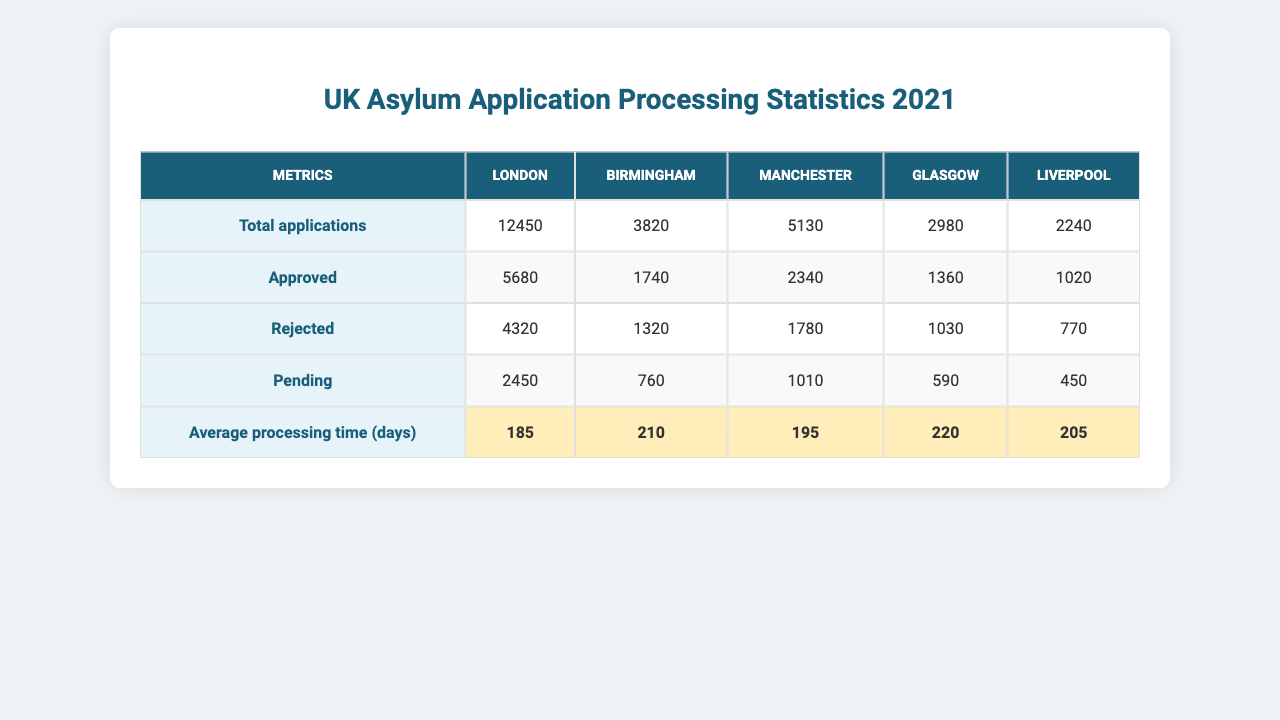What is the total number of asylum applications in London? The table shows that London has 12,450 asylum applications listed under "Total applications."
Answer: 12,450 How many applications were approved in Birmingham? According to the table, Birmingham has 1,740 applications approved.
Answer: 1,740 Which city had the highest number of rejected applications? By examining the "Rejected" column, London has the highest number of rejected applications at 4,320.
Answer: London What is the average processing time for applications in Manchester? The table indicates that the average processing time in Manchester is 195 days.
Answer: 195 days How many pending applications are there in Liverpool? The table shows that Liverpool has 450 pending applications.
Answer: 450 Which city had the lowest total asylum applications? Reviewing the "Total applications" row, Liverpool has the lowest total with 2,240 applications.
Answer: Liverpool What is the sum of approved applications across all cities? The approved applications are: London (5,680) + Birmingham (1,740) + Manchester (2,340) + Glasgow (1,360) + Liverpool (1,020), totaling 12,140 approved applications.
Answer: 12,140 Is the average processing time in Glasgow higher than in Birmingham? Glasgow has an average processing time of 220 days, while Birmingham has 210 days, indicating that Glasgow is indeed higher.
Answer: Yes What is the difference in total applications between London and Birmingham? The difference is calculated as 12,450 (London) - 3,820 (Birmingham) = 8,630 applications.
Answer: 8,630 Which city has the highest number of pending applications? Looking at the "Pending" column, London has 2,450 pending applications, which is the highest among all cities listed.
Answer: London If we consider the total number of applications and their approval rates, which city has the highest approval rate? The approval rate is calculated by dividing approved applications by total applications. For example, for London, it's 5,680/12,450 = ~45.7%. Doing this for all cities shows that Birmingham has the highest approval rate at approximately 45.7%.
Answer: Birmingham What is the average processing time of applications for cities with more than 5,000 total applications? The cities are London (185 days) and Manchester (195 days). The average is (185 + 195)/2 = 190 days.
Answer: 190 days 